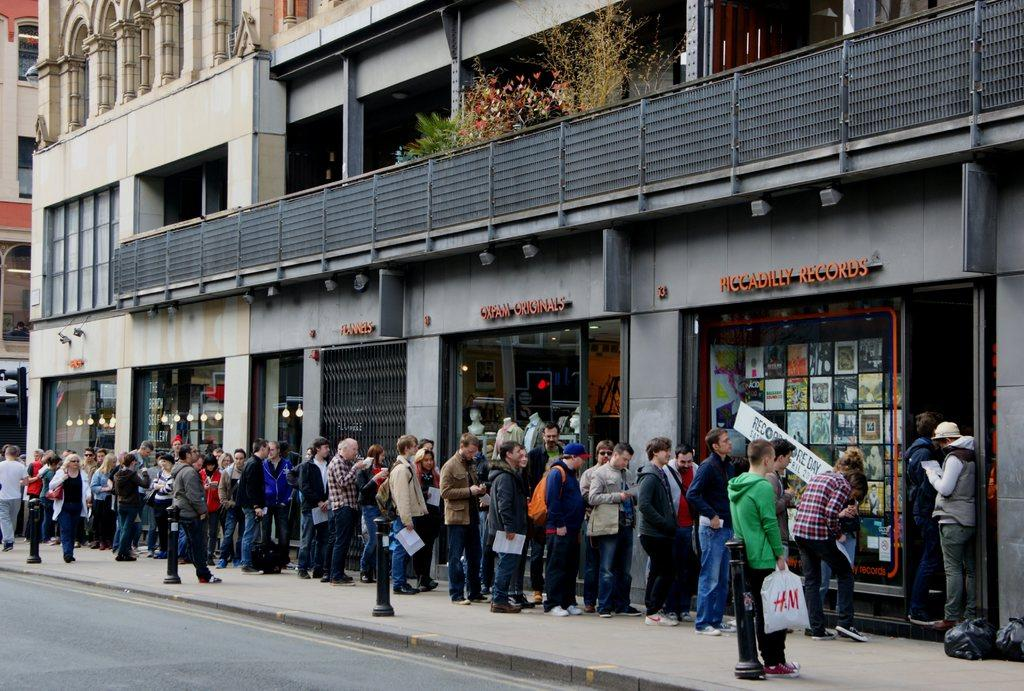Provide a one-sentence caption for the provided image. People are lined up outside of Piccadilly Records, including someone with an H&M bag. 